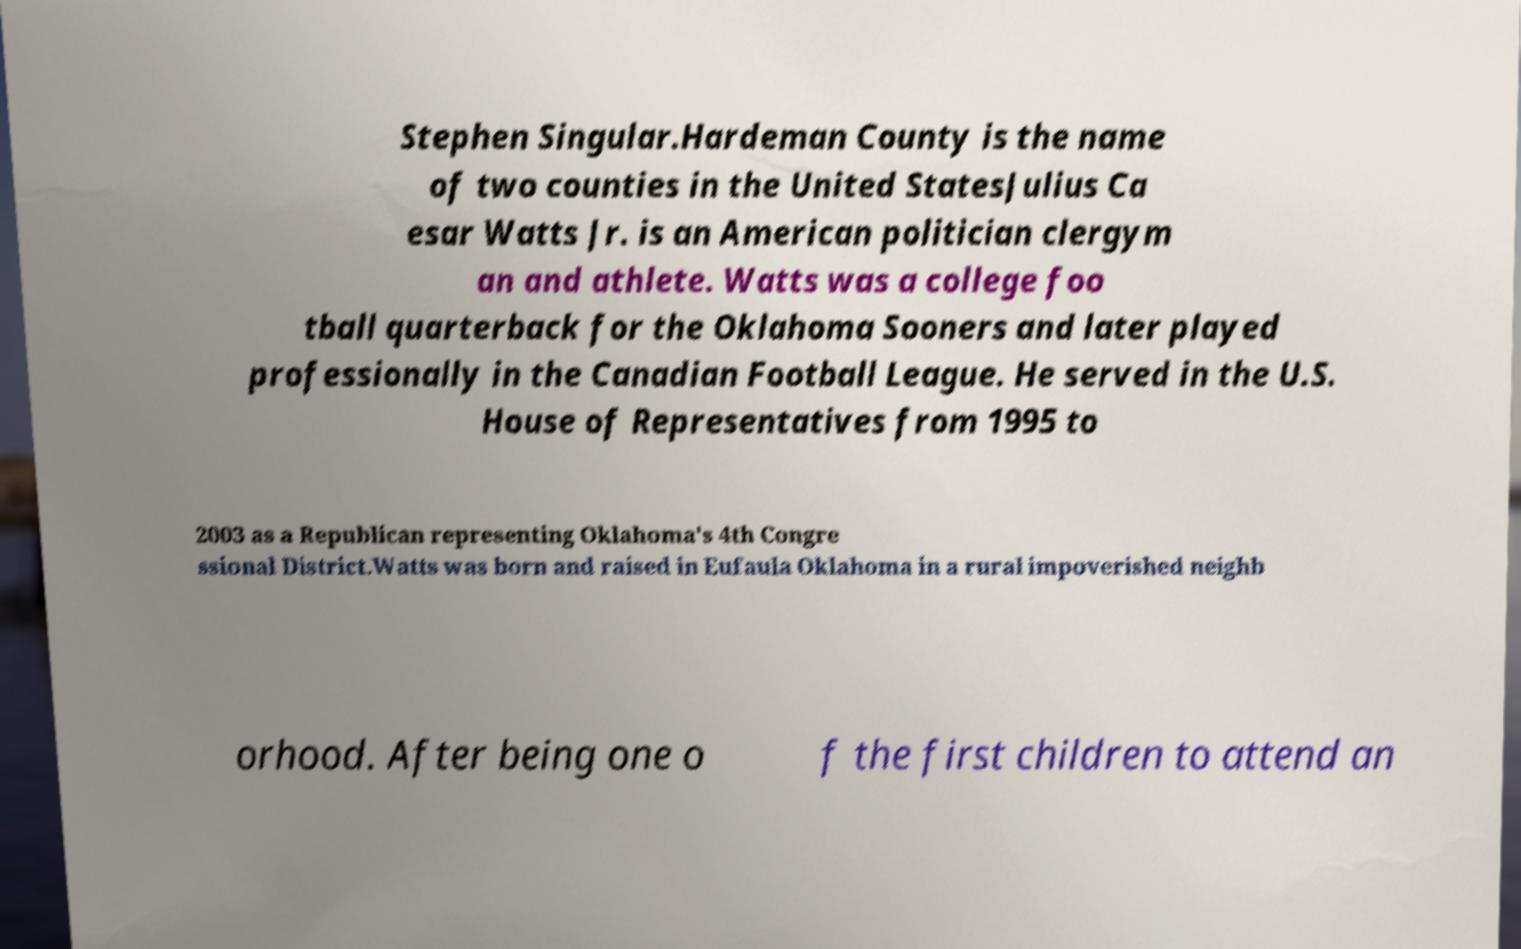What messages or text are displayed in this image? I need them in a readable, typed format. Stephen Singular.Hardeman County is the name of two counties in the United StatesJulius Ca esar Watts Jr. is an American politician clergym an and athlete. Watts was a college foo tball quarterback for the Oklahoma Sooners and later played professionally in the Canadian Football League. He served in the U.S. House of Representatives from 1995 to 2003 as a Republican representing Oklahoma's 4th Congre ssional District.Watts was born and raised in Eufaula Oklahoma in a rural impoverished neighb orhood. After being one o f the first children to attend an 